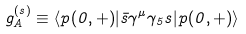Convert formula to latex. <formula><loc_0><loc_0><loc_500><loc_500>g ^ { ( s ) } _ { A } \equiv \langle p ( { 0 } , + ) | \bar { s } \gamma ^ { \mu } \gamma _ { 5 } s | p ( { 0 } , + ) \rangle</formula> 